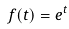Convert formula to latex. <formula><loc_0><loc_0><loc_500><loc_500>f ( t ) = e ^ { t }</formula> 